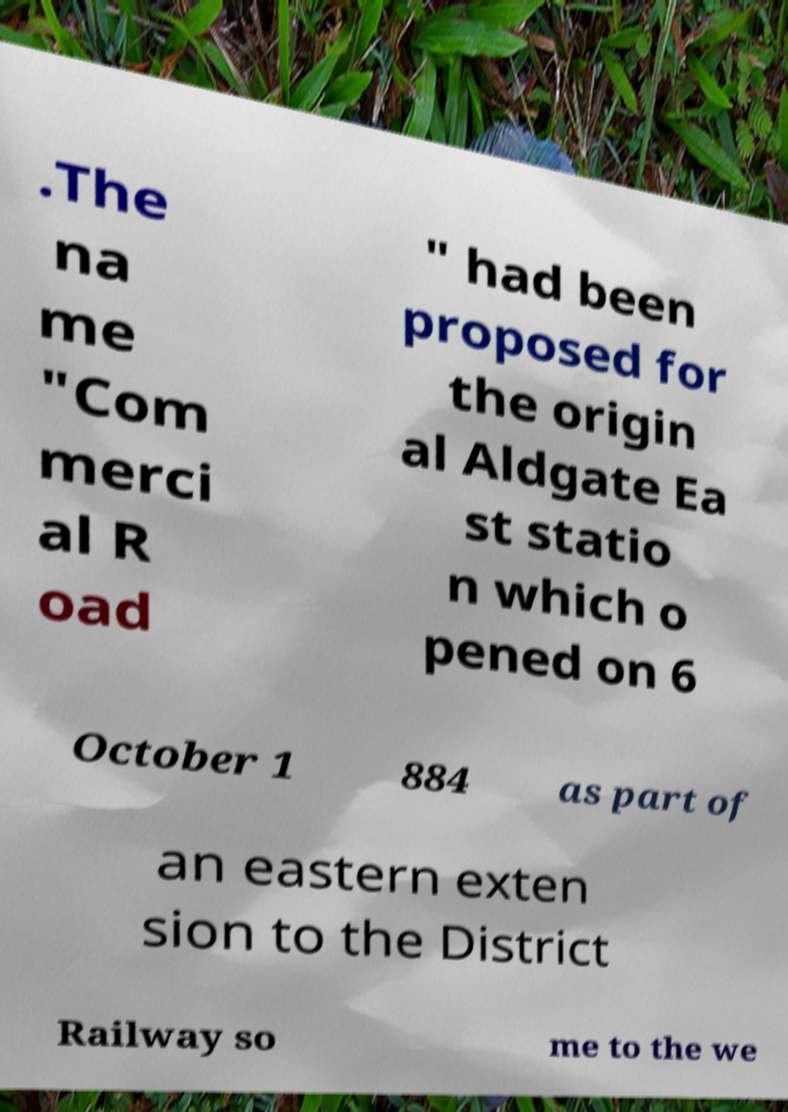For documentation purposes, I need the text within this image transcribed. Could you provide that? .The na me "Com merci al R oad " had been proposed for the origin al Aldgate Ea st statio n which o pened on 6 October 1 884 as part of an eastern exten sion to the District Railway so me to the we 